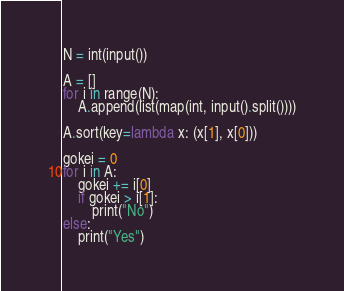<code> <loc_0><loc_0><loc_500><loc_500><_Python_>N = int(input())

A = []
for i in range(N):
    A.append(list(map(int, input().split())))

A.sort(key=lambda x: (x[1], x[0]))

gokei = 0
for i in A:
    gokei += i[0]
    if gokei > i[1]:
        print("No")
else:
    print("Yes")</code> 